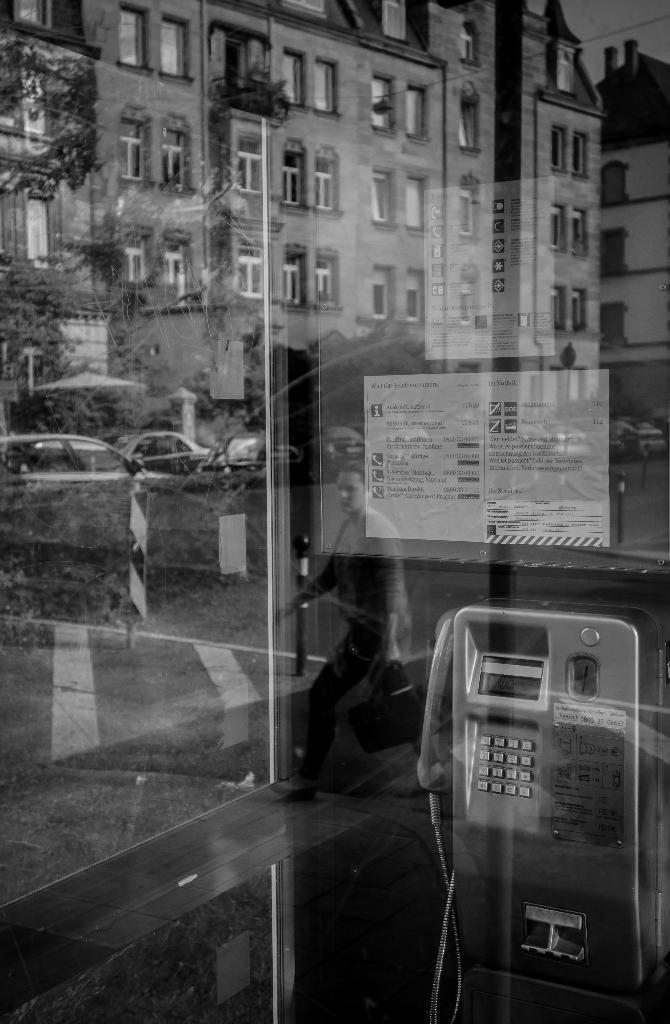In one or two sentences, can you explain what this image depicts? This is a black and white image. In this image we can see public telephone booth, buildings, windows, trees, motor vehicles on the road and sky. 